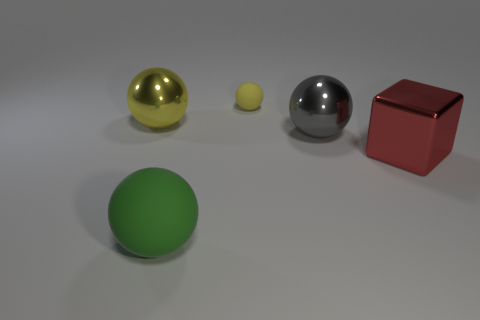Are there any other spheres that have the same color as the small rubber ball?
Ensure brevity in your answer.  Yes. What size is the metal thing that is the same color as the tiny rubber thing?
Give a very brief answer. Large. Is the size of the matte thing left of the small rubber sphere the same as the red thing behind the green ball?
Offer a very short reply. Yes. What is the size of the metallic ball that is behind the gray shiny ball?
Provide a short and direct response. Large. What material is the large thing that is the same color as the tiny matte thing?
Give a very brief answer. Metal. There is a matte object that is the same size as the metal cube; what color is it?
Your answer should be compact. Green. Is the size of the green ball the same as the gray sphere?
Ensure brevity in your answer.  Yes. What is the size of the object that is both left of the large gray sphere and in front of the gray shiny thing?
Offer a very short reply. Large. What number of metal objects are either tiny blue cylinders or green things?
Offer a very short reply. 0. Is the number of yellow metal objects left of the red block greater than the number of gray objects?
Ensure brevity in your answer.  No. 